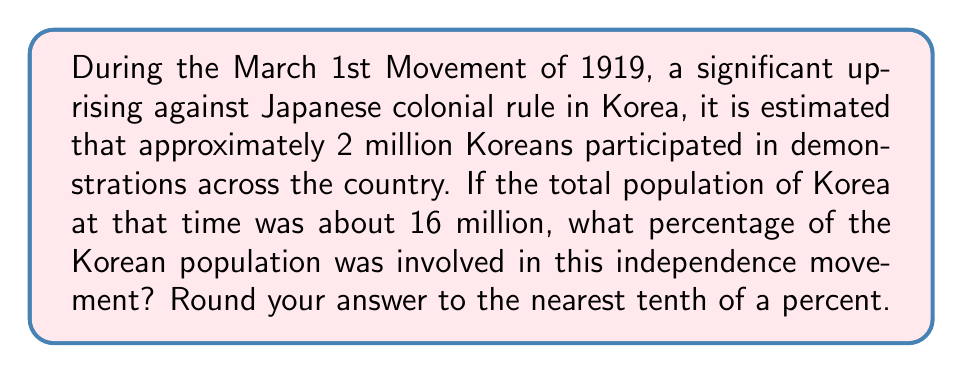Help me with this question. To calculate the percentage of the Korean population involved in the independence movement, we need to use the following formula:

$$ \text{Percentage} = \frac{\text{Number of participants}}{\text{Total population}} \times 100\% $$

Given:
- Number of participants: 2 million
- Total population: 16 million

Let's substitute these values into the formula:

$$ \text{Percentage} = \frac{2,000,000}{16,000,000} \times 100\% $$

Now, let's solve this step by step:

1) First, divide 2,000,000 by 16,000,000:
   $$ \frac{2,000,000}{16,000,000} = 0.125 $$

2) Multiply this result by 100 to convert to a percentage:
   $$ 0.125 \times 100 = 12.5\% $$

3) The question asks to round to the nearest tenth of a percent, but 12.5% is already in that form, so no further rounding is necessary.

Therefore, approximately 12.5% of the Korean population was involved in the March 1st Movement of 1919.
Answer: 12.5% 